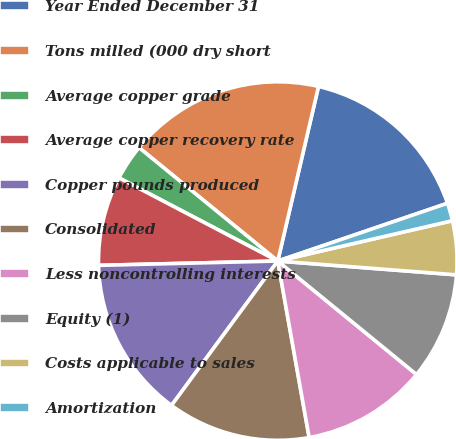Convert chart. <chart><loc_0><loc_0><loc_500><loc_500><pie_chart><fcel>Year Ended December 31<fcel>Tons milled (000 dry short<fcel>Average copper grade<fcel>Average copper recovery rate<fcel>Copper pounds produced<fcel>Consolidated<fcel>Less noncontrolling interests<fcel>Equity (1)<fcel>Costs applicable to sales<fcel>Amortization<nl><fcel>16.13%<fcel>17.74%<fcel>3.23%<fcel>8.06%<fcel>14.52%<fcel>12.9%<fcel>11.29%<fcel>9.68%<fcel>4.84%<fcel>1.61%<nl></chart> 